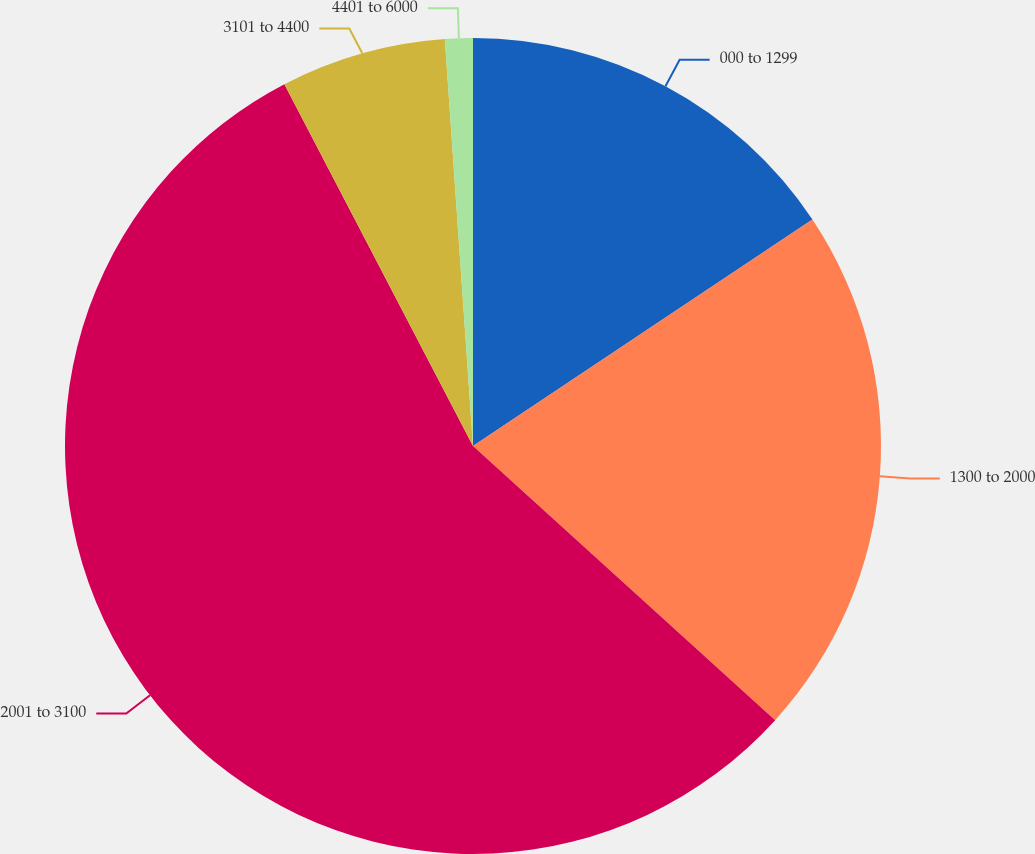Convert chart. <chart><loc_0><loc_0><loc_500><loc_500><pie_chart><fcel>000 to 1299<fcel>1300 to 2000<fcel>2001 to 3100<fcel>3101 to 4400<fcel>4401 to 6000<nl><fcel>15.64%<fcel>21.09%<fcel>55.63%<fcel>6.55%<fcel>1.1%<nl></chart> 